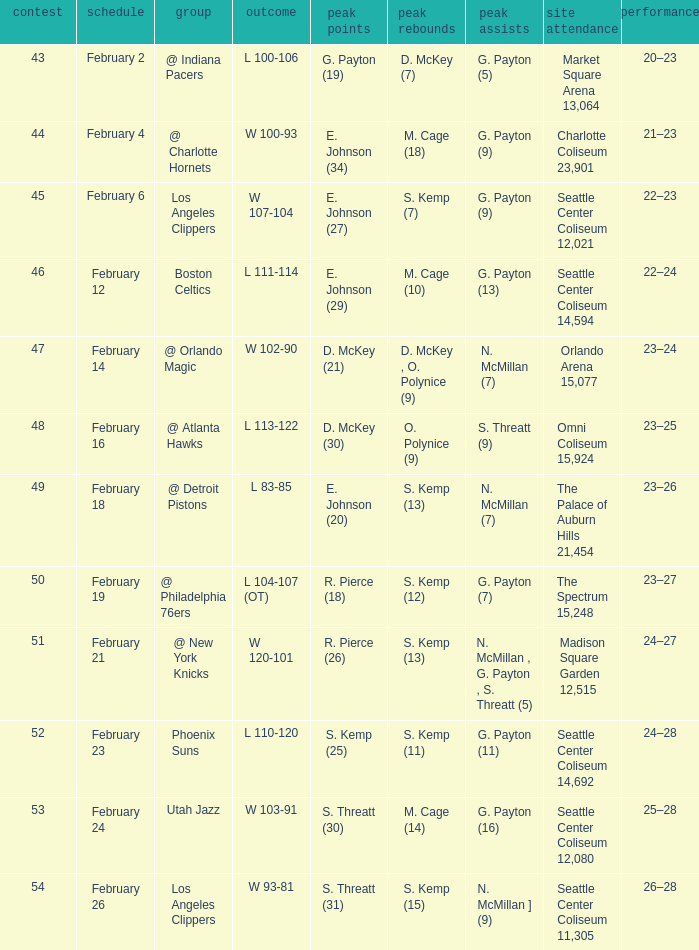What is the record for the Utah Jazz? 25–28. 